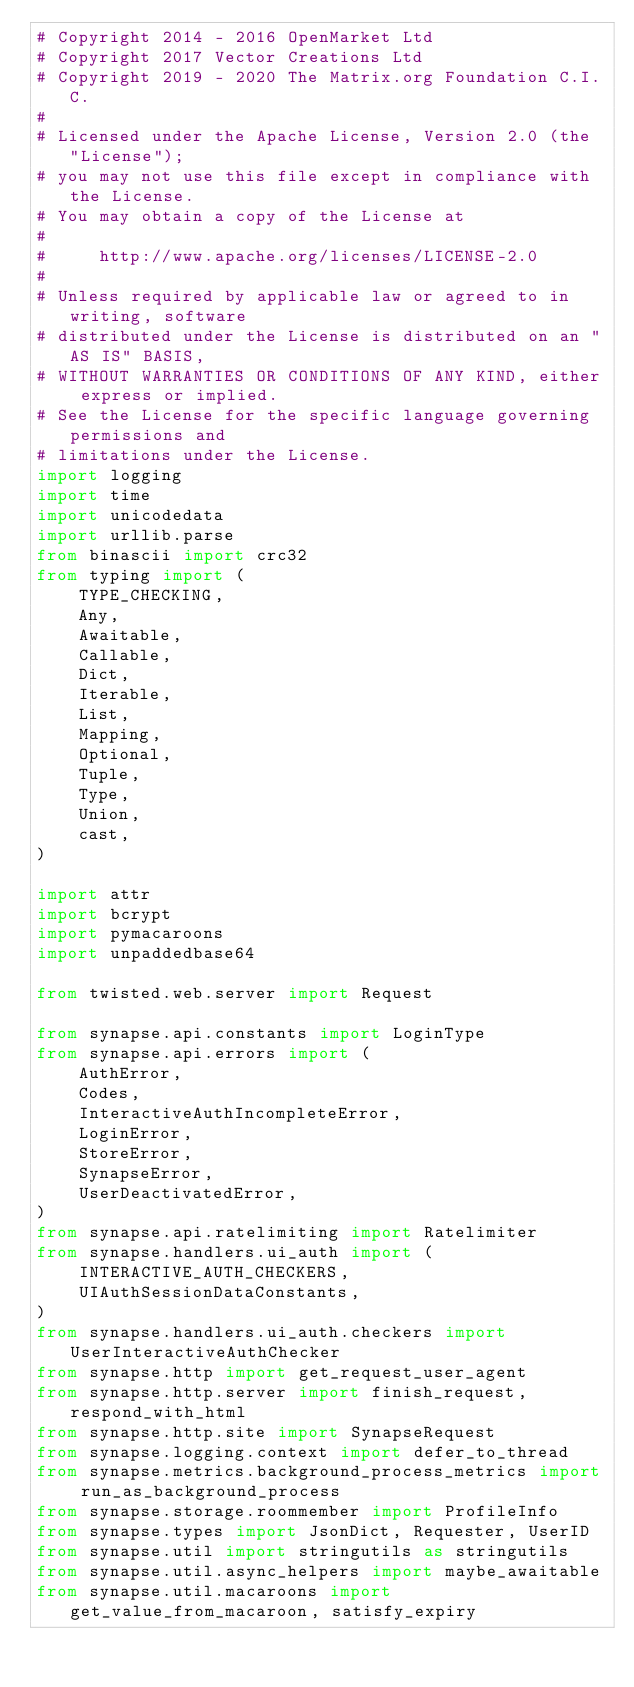<code> <loc_0><loc_0><loc_500><loc_500><_Python_># Copyright 2014 - 2016 OpenMarket Ltd
# Copyright 2017 Vector Creations Ltd
# Copyright 2019 - 2020 The Matrix.org Foundation C.I.C.
#
# Licensed under the Apache License, Version 2.0 (the "License");
# you may not use this file except in compliance with the License.
# You may obtain a copy of the License at
#
#     http://www.apache.org/licenses/LICENSE-2.0
#
# Unless required by applicable law or agreed to in writing, software
# distributed under the License is distributed on an "AS IS" BASIS,
# WITHOUT WARRANTIES OR CONDITIONS OF ANY KIND, either express or implied.
# See the License for the specific language governing permissions and
# limitations under the License.
import logging
import time
import unicodedata
import urllib.parse
from binascii import crc32
from typing import (
    TYPE_CHECKING,
    Any,
    Awaitable,
    Callable,
    Dict,
    Iterable,
    List,
    Mapping,
    Optional,
    Tuple,
    Type,
    Union,
    cast,
)

import attr
import bcrypt
import pymacaroons
import unpaddedbase64

from twisted.web.server import Request

from synapse.api.constants import LoginType
from synapse.api.errors import (
    AuthError,
    Codes,
    InteractiveAuthIncompleteError,
    LoginError,
    StoreError,
    SynapseError,
    UserDeactivatedError,
)
from synapse.api.ratelimiting import Ratelimiter
from synapse.handlers.ui_auth import (
    INTERACTIVE_AUTH_CHECKERS,
    UIAuthSessionDataConstants,
)
from synapse.handlers.ui_auth.checkers import UserInteractiveAuthChecker
from synapse.http import get_request_user_agent
from synapse.http.server import finish_request, respond_with_html
from synapse.http.site import SynapseRequest
from synapse.logging.context import defer_to_thread
from synapse.metrics.background_process_metrics import run_as_background_process
from synapse.storage.roommember import ProfileInfo
from synapse.types import JsonDict, Requester, UserID
from synapse.util import stringutils as stringutils
from synapse.util.async_helpers import maybe_awaitable
from synapse.util.macaroons import get_value_from_macaroon, satisfy_expiry</code> 